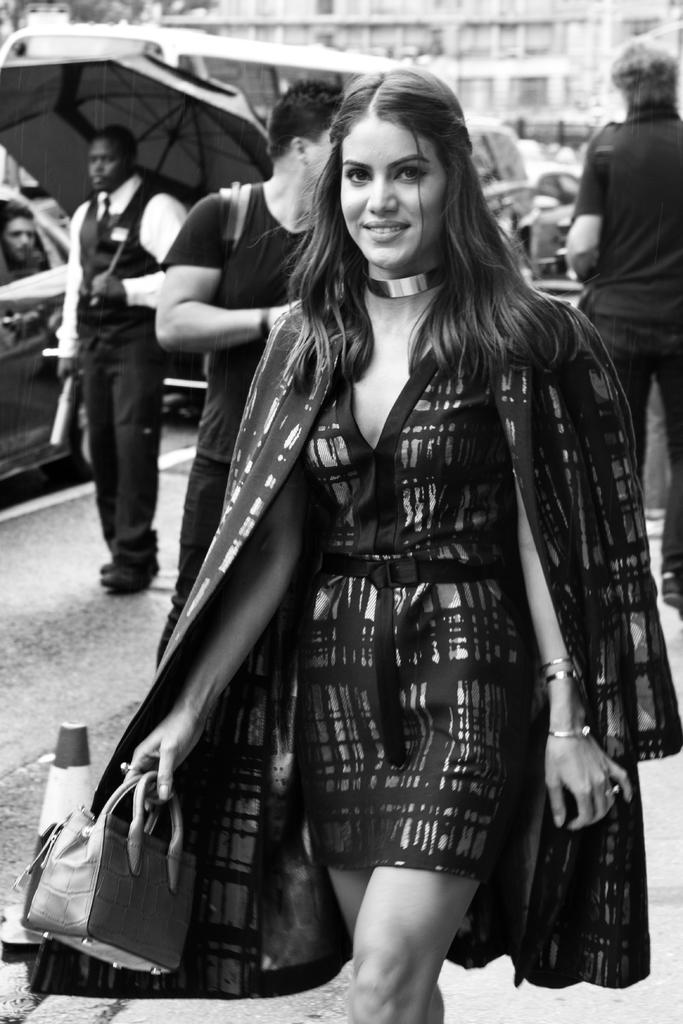What is the woman in the image doing? The woman is walking on a road. What is the woman carrying in the image? The woman is holding a handbag. Are there any other people in the image? Yes, there are men walking behind her. What type of flowers can be seen growing on the woman's head in the image? There are no flowers visible on the woman's head in the image. 